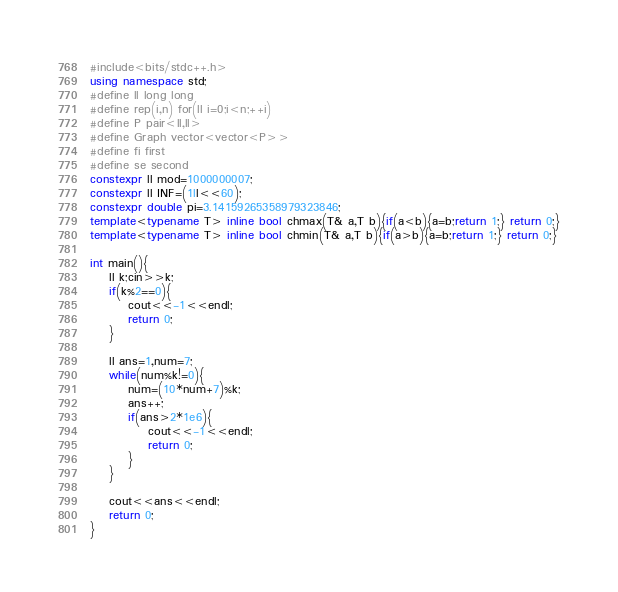Convert code to text. <code><loc_0><loc_0><loc_500><loc_500><_C++_>#include<bits/stdc++.h>
using namespace std;
#define ll long long
#define rep(i,n) for(ll i=0;i<n;++i)
#define P pair<ll,ll>
#define Graph vector<vector<P>>
#define fi first
#define se second
constexpr ll mod=1000000007;
constexpr ll INF=(1ll<<60);
constexpr double pi=3.14159265358979323846;
template<typename T> inline bool chmax(T& a,T b){if(a<b){a=b;return 1;} return 0;}
template<typename T> inline bool chmin(T& a,T b){if(a>b){a=b;return 1;} return 0;}

int main(){
    ll k;cin>>k;
    if(k%2==0){
        cout<<-1<<endl;
        return 0;
    }

    ll ans=1,num=7;
    while(num%k!=0){
        num=(10*num+7)%k;
        ans++;
        if(ans>2*1e6){
            cout<<-1<<endl;
            return 0;
        }
    }

    cout<<ans<<endl;
    return 0;
}</code> 